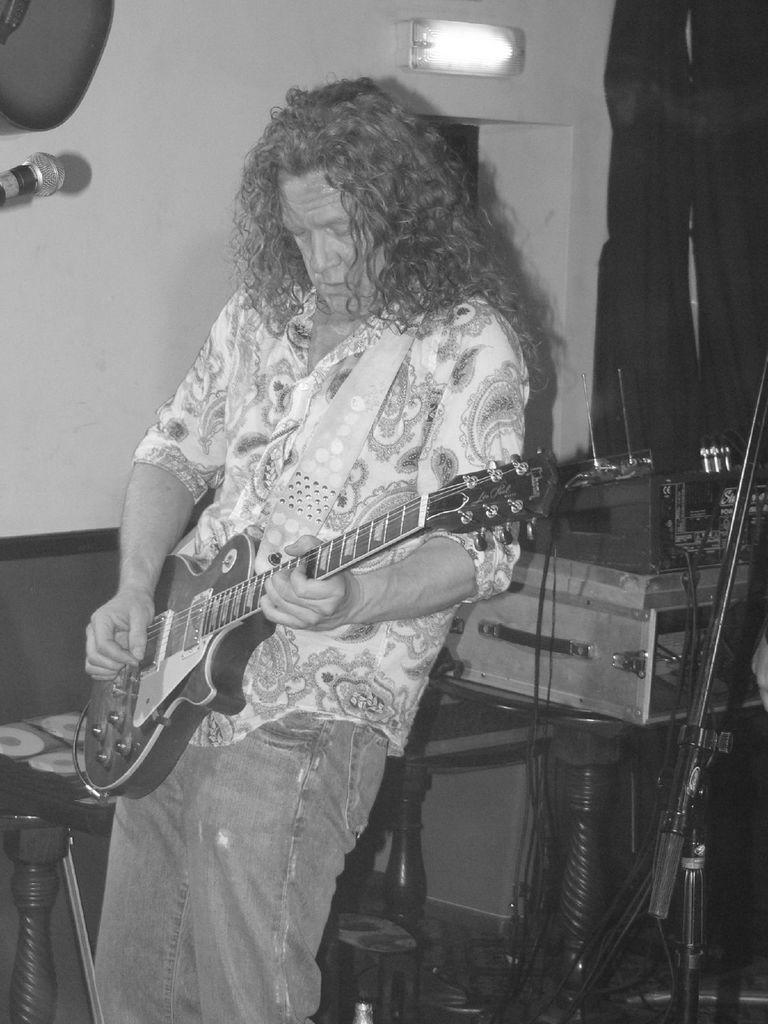Please provide a concise description of this image. In this picture we can see a man with long hair, wearing pattern design white shirt is playing a guitar , Behind we can see the aluminium box with some musical instrument and antennas, Behind him a white wall and bulb on it. on the left corner we can see the table and a microphone with stand. 